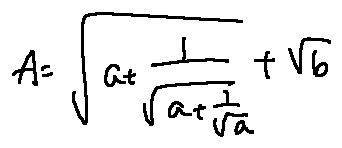Convert formula to latex. <formula><loc_0><loc_0><loc_500><loc_500>A = \sqrt { a + \frac { 1 } { \sqrt { a + \frac { 1 } { \sqrt { a } } } } } + \sqrt { b }</formula> 